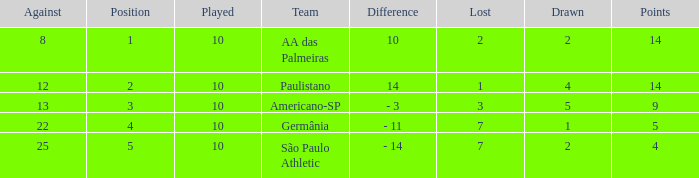What is the highest Drawn when the lost is 7 and the points are more than 4, and the against is less than 22? None. 